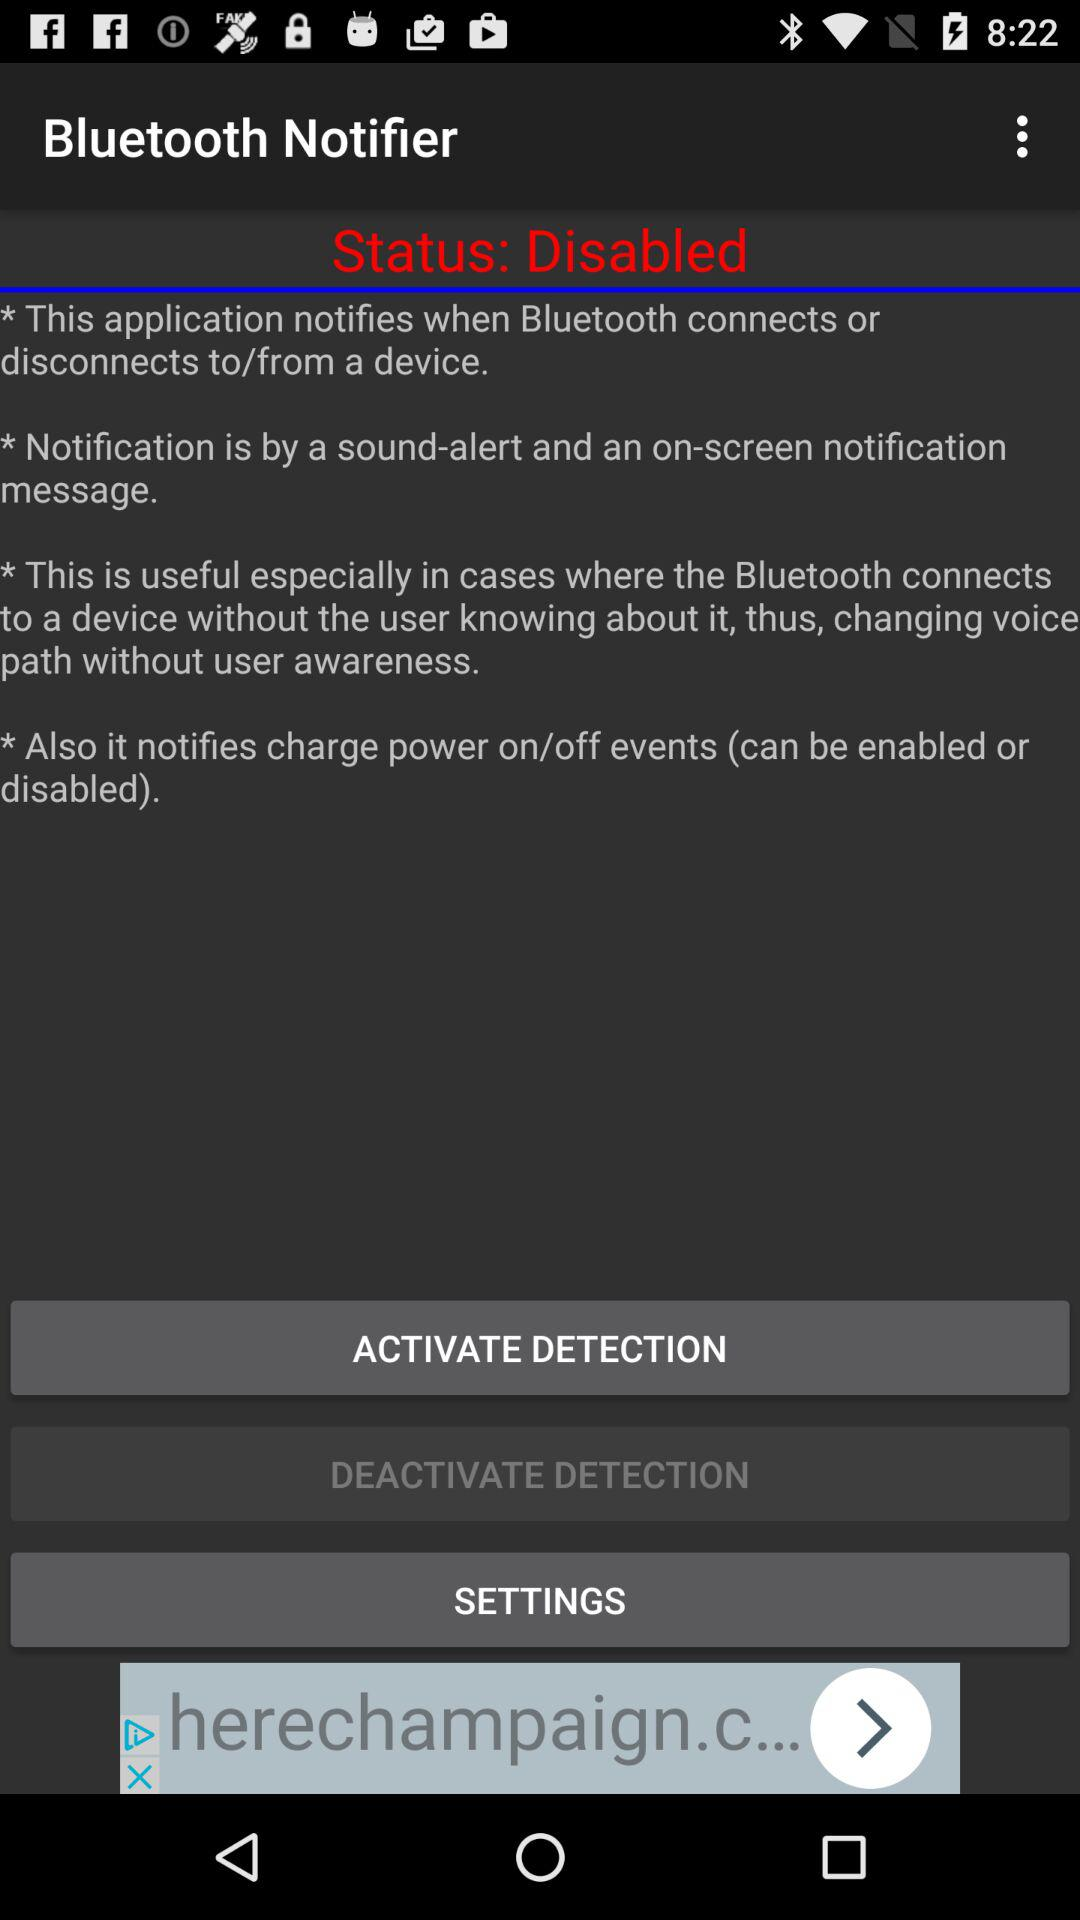What is the application name? The application name is "Bluetooth Notifier". 